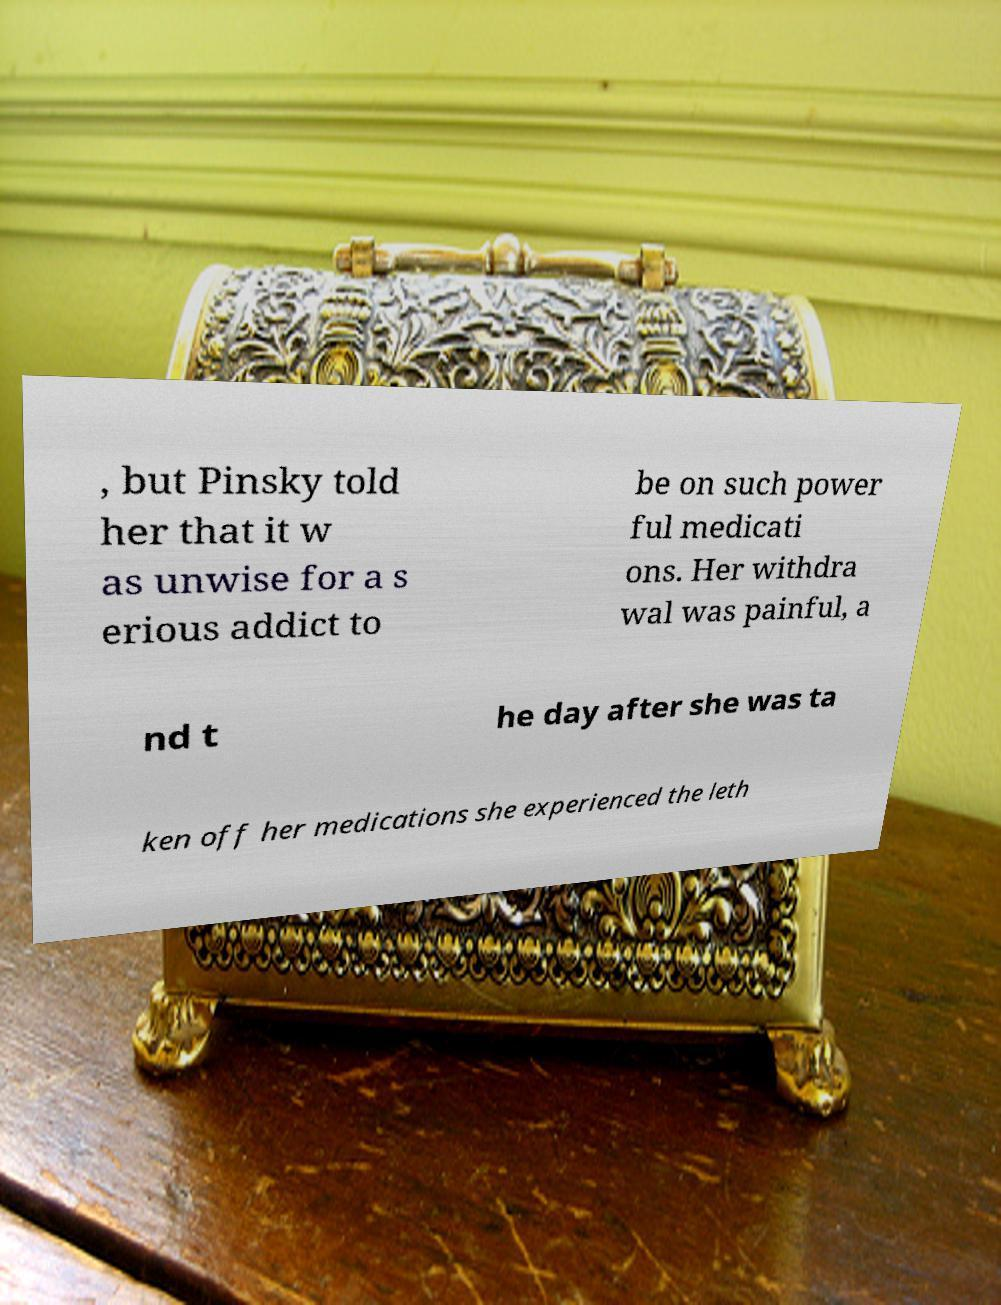Could you extract and type out the text from this image? , but Pinsky told her that it w as unwise for a s erious addict to be on such power ful medicati ons. Her withdra wal was painful, a nd t he day after she was ta ken off her medications she experienced the leth 